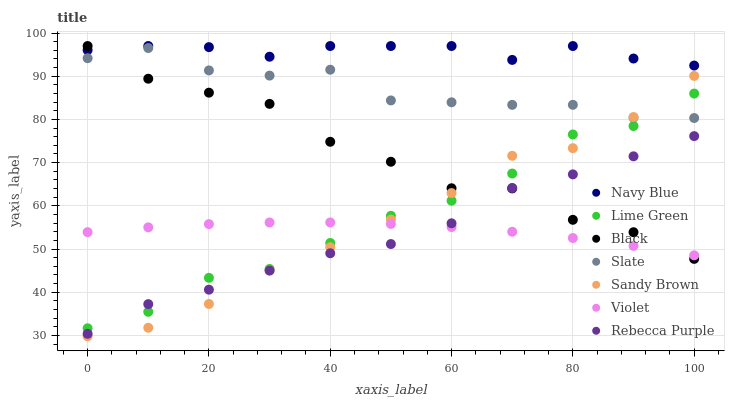Does Rebecca Purple have the minimum area under the curve?
Answer yes or no. Yes. Does Navy Blue have the maximum area under the curve?
Answer yes or no. Yes. Does Slate have the minimum area under the curve?
Answer yes or no. No. Does Slate have the maximum area under the curve?
Answer yes or no. No. Is Violet the smoothest?
Answer yes or no. Yes. Is Black the roughest?
Answer yes or no. Yes. Is Navy Blue the smoothest?
Answer yes or no. No. Is Navy Blue the roughest?
Answer yes or no. No. Does Sandy Brown have the lowest value?
Answer yes or no. Yes. Does Slate have the lowest value?
Answer yes or no. No. Does Black have the highest value?
Answer yes or no. Yes. Does Slate have the highest value?
Answer yes or no. No. Is Rebecca Purple less than Navy Blue?
Answer yes or no. Yes. Is Navy Blue greater than Rebecca Purple?
Answer yes or no. Yes. Does Violet intersect Rebecca Purple?
Answer yes or no. Yes. Is Violet less than Rebecca Purple?
Answer yes or no. No. Is Violet greater than Rebecca Purple?
Answer yes or no. No. Does Rebecca Purple intersect Navy Blue?
Answer yes or no. No. 